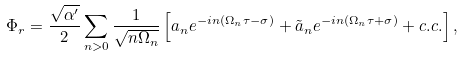Convert formula to latex. <formula><loc_0><loc_0><loc_500><loc_500>\Phi _ { r } = \frac { \sqrt { \alpha ^ { \prime } } } { 2 } \sum _ { n > 0 } \frac { 1 } { \sqrt { n \Omega _ { n } } } \left [ a _ { n } e ^ { - i n ( \Omega _ { n } \tau - \sigma ) } + \tilde { a } _ { n } e ^ { - i n ( \Omega _ { n } \tau + \sigma ) } + c . c . \right ] ,</formula> 